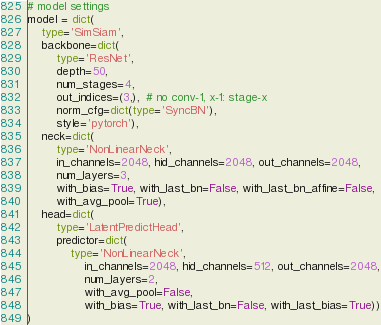Convert code to text. <code><loc_0><loc_0><loc_500><loc_500><_Python_># model settings
model = dict(
    type='SimSiam',
    backbone=dict(
        type='ResNet',
        depth=50,
        num_stages=4,
        out_indices=(3,),  # no conv-1, x-1: stage-x
        norm_cfg=dict(type='SyncBN'),
        style='pytorch'),
    neck=dict(
        type='NonLinearNeck',
        in_channels=2048, hid_channels=2048, out_channels=2048,
        num_layers=3,
        with_bias=True, with_last_bn=False, with_last_bn_affine=False,
        with_avg_pool=True),
    head=dict(
        type='LatentPredictHead',
        predictor=dict(
            type='NonLinearNeck',
                in_channels=2048, hid_channels=512, out_channels=2048,
                num_layers=2,
                with_avg_pool=False,
                with_bias=True, with_last_bn=False, with_last_bias=True))
)
</code> 